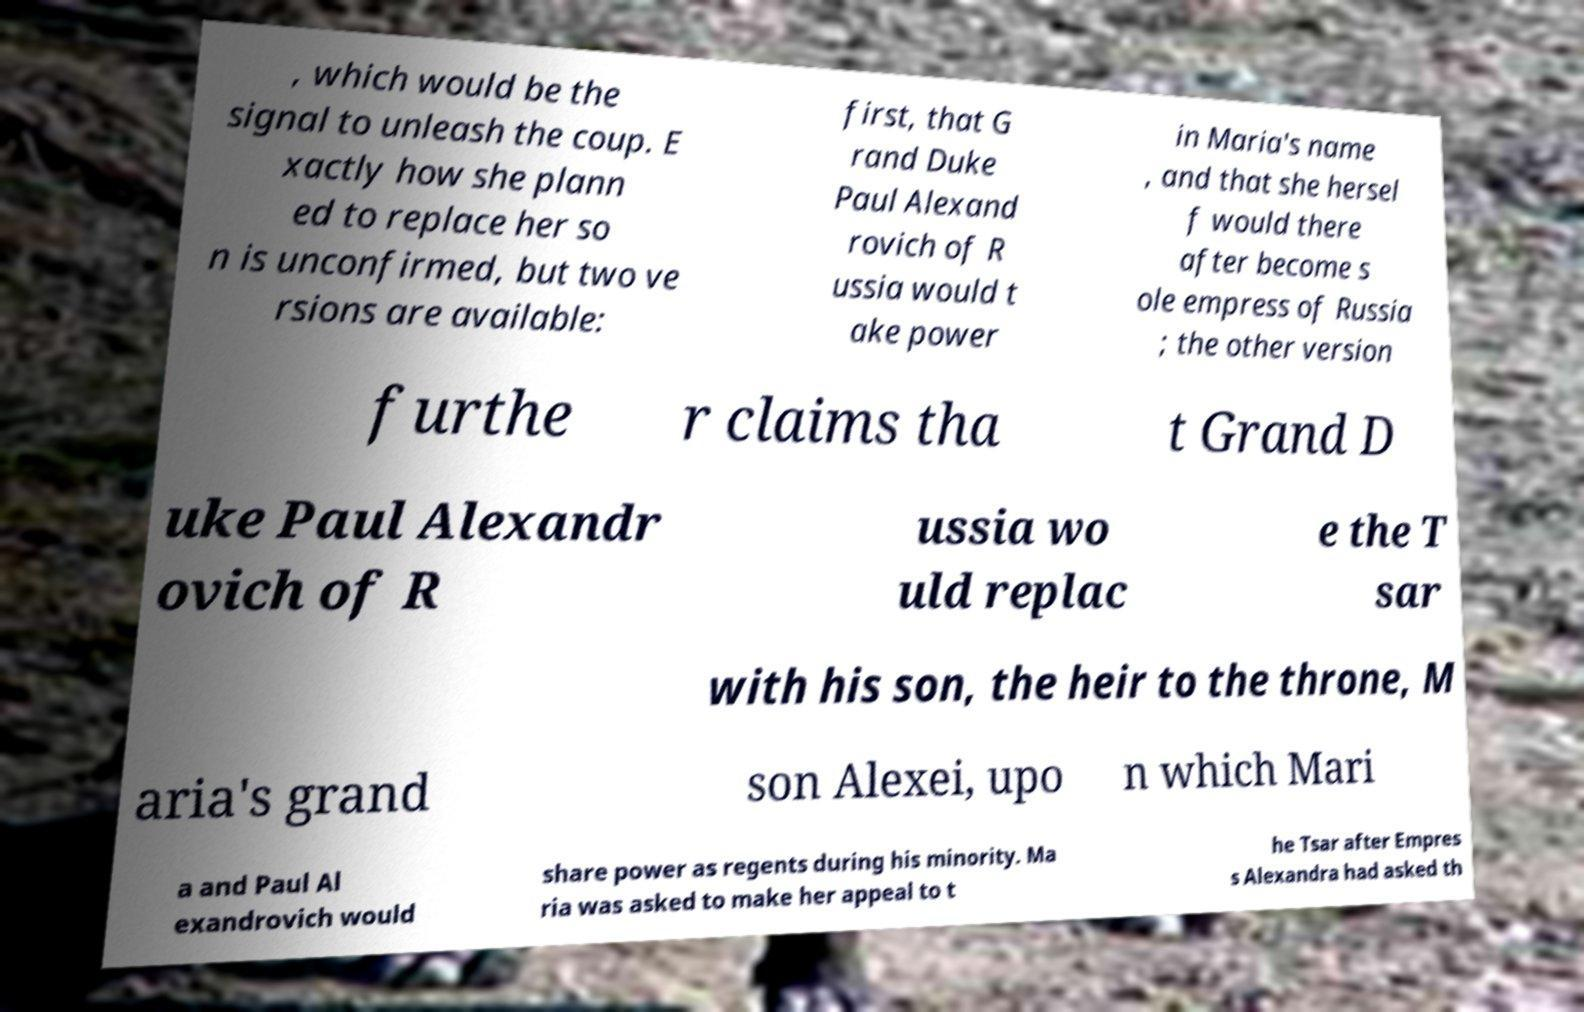Could you extract and type out the text from this image? , which would be the signal to unleash the coup. E xactly how she plann ed to replace her so n is unconfirmed, but two ve rsions are available: first, that G rand Duke Paul Alexand rovich of R ussia would t ake power in Maria's name , and that she hersel f would there after become s ole empress of Russia ; the other version furthe r claims tha t Grand D uke Paul Alexandr ovich of R ussia wo uld replac e the T sar with his son, the heir to the throne, M aria's grand son Alexei, upo n which Mari a and Paul Al exandrovich would share power as regents during his minority. Ma ria was asked to make her appeal to t he Tsar after Empres s Alexandra had asked th 